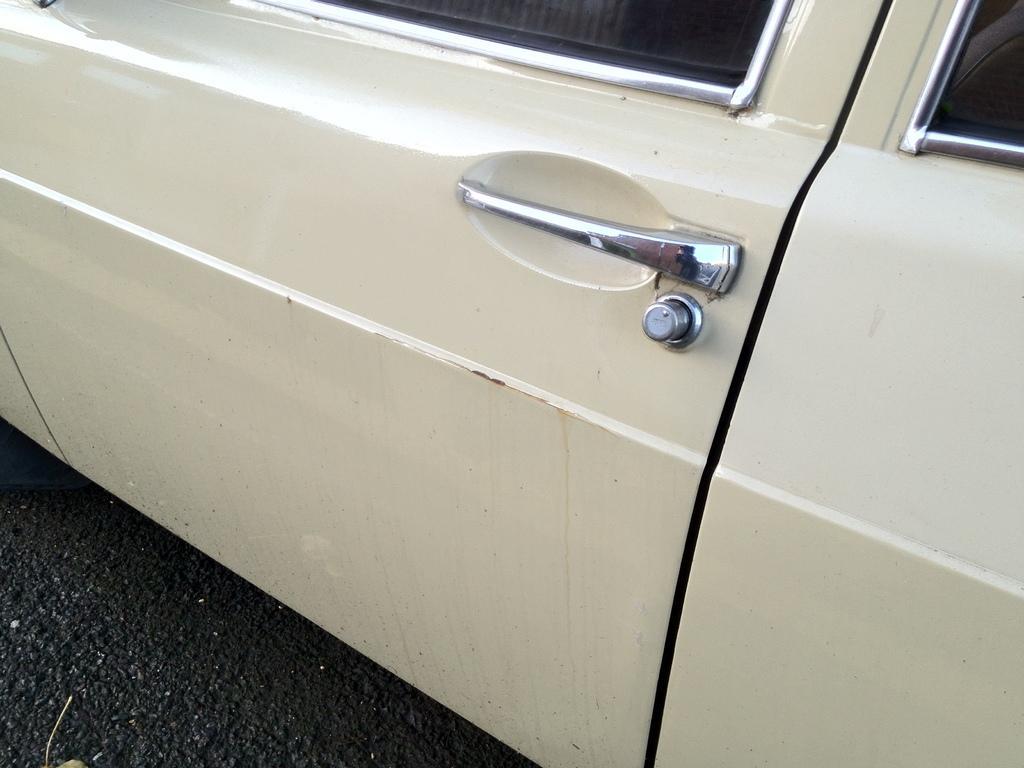Can you describe this image briefly? In this picture we can see a vehicle here, we can see a window, a door and a handle of the vehicle. 